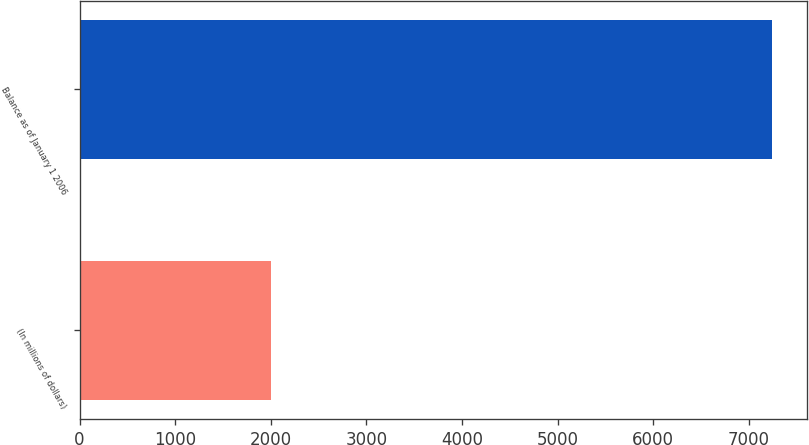<chart> <loc_0><loc_0><loc_500><loc_500><bar_chart><fcel>(In millions of dollars)<fcel>Balance as of January 1 2006<nl><fcel>2006<fcel>7246<nl></chart> 